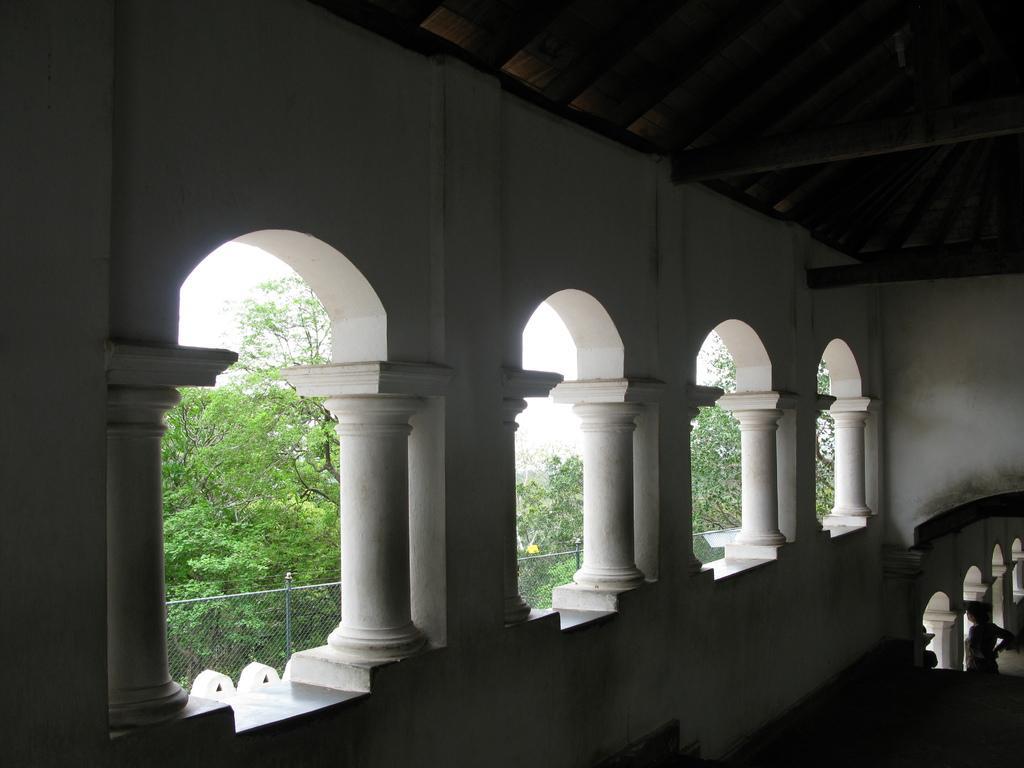In one or two sentences, can you explain what this image depicts? In this image we can see a building with pillars. On the backside we can see some group of trees, a fence and the sky. On the right side we can see a person standing. 